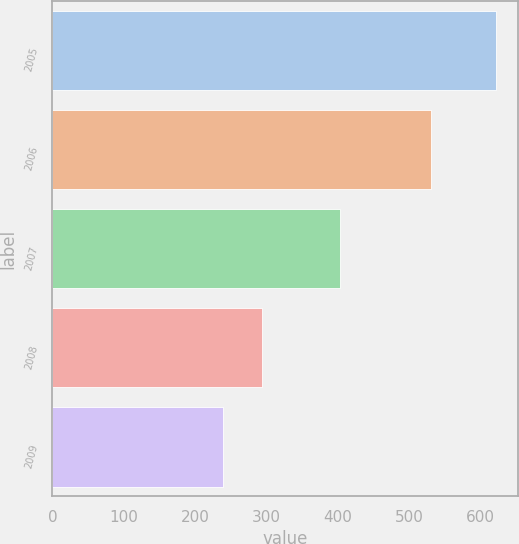Convert chart to OTSL. <chart><loc_0><loc_0><loc_500><loc_500><bar_chart><fcel>2005<fcel>2006<fcel>2007<fcel>2008<fcel>2009<nl><fcel>622<fcel>531<fcel>403<fcel>294<fcel>239<nl></chart> 